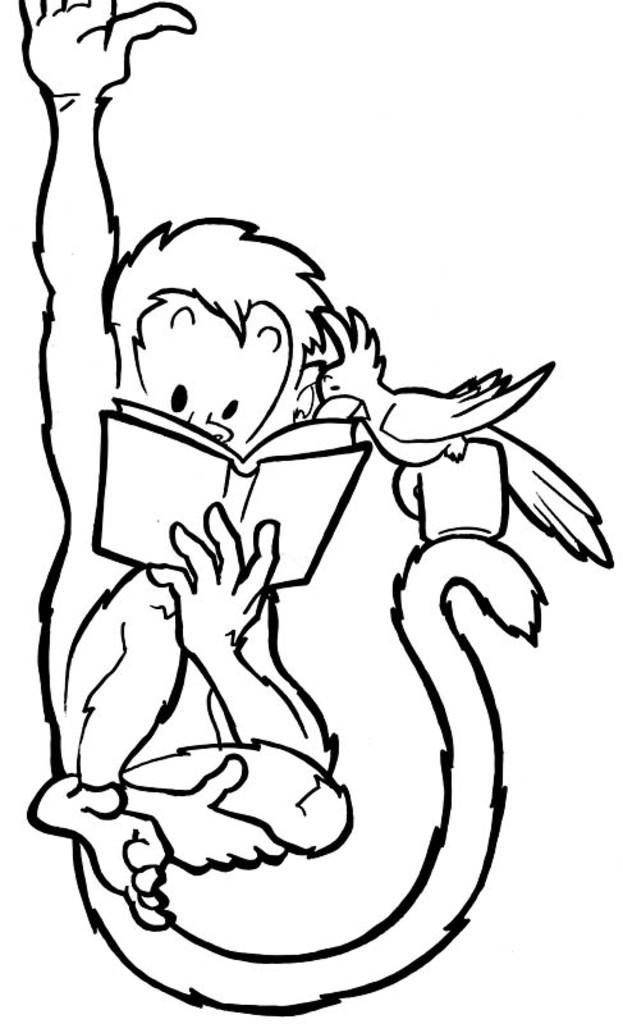What is the main subject of the image? There is a picture of an animal in the image. What is the animal doing in the image? The animal is holding a book in its hand. What other living creature can be seen in the image? There is a bird in the image. Where is the bird located in the image? The bird is on a cup. What type of bread is the daughter eating in the image? There is no daughter or bread present in the image. 